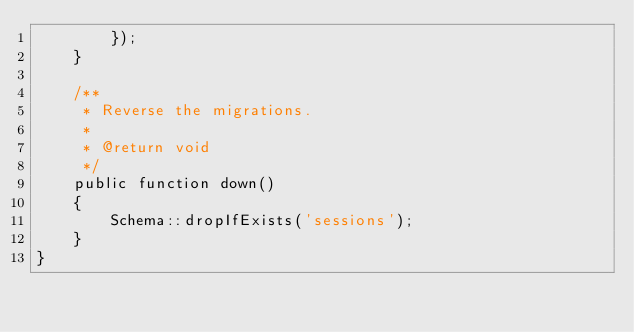<code> <loc_0><loc_0><loc_500><loc_500><_PHP_>        });
    }

    /**
     * Reverse the migrations.
     *
     * @return void
     */
    public function down()
    {
        Schema::dropIfExists('sessions');
    }
}
</code> 